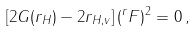Convert formula to latex. <formula><loc_0><loc_0><loc_500><loc_500>\left [ 2 G ( r _ { H } ) - 2 r _ { H , v } \right ] ( ^ { r } F ) ^ { 2 } = 0 \, ,</formula> 